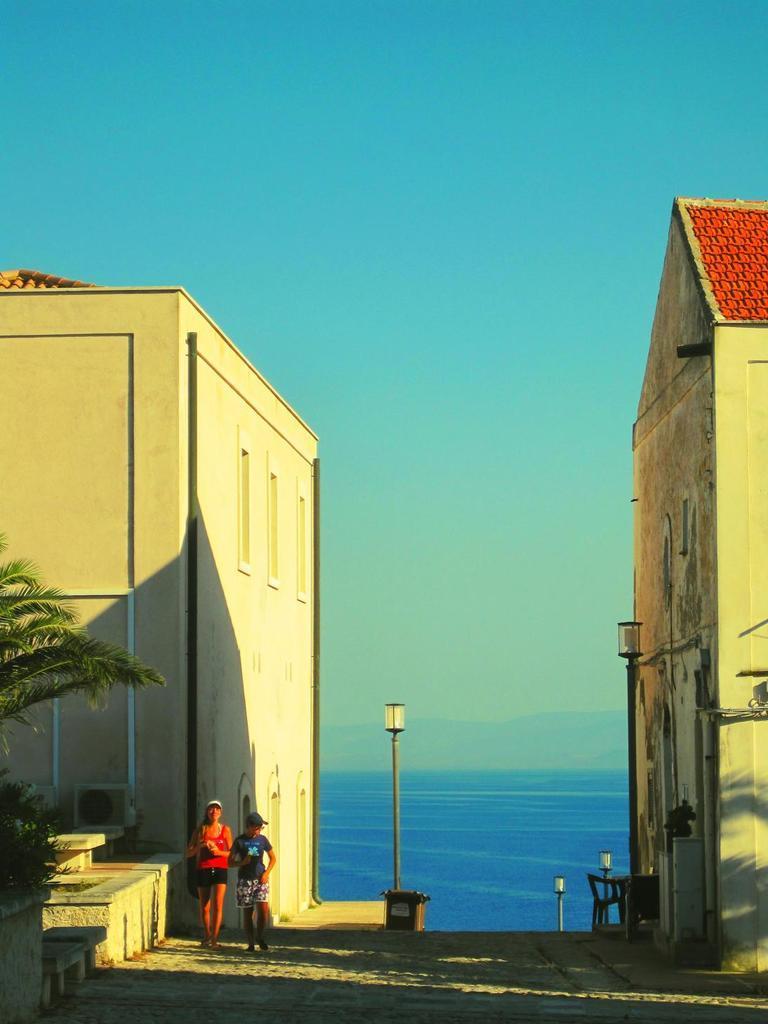Could you give a brief overview of what you see in this image? In the center of the image we can see the hills, water, poles, lights. In the background of the image we can see the buildings, windows. On the left side of the image we can see the trees and two people are walking and wearing caps. At the bottom of the image we can see the road. At the top of the image we can see the sky. 